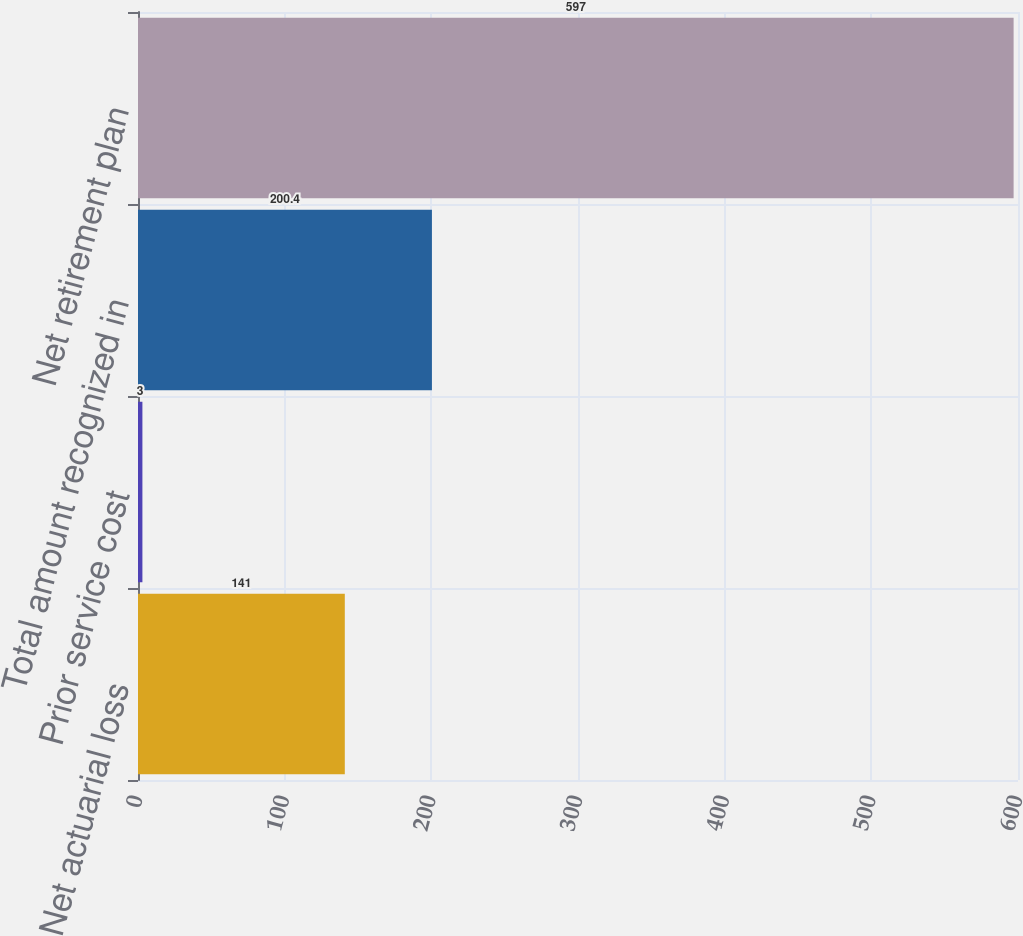<chart> <loc_0><loc_0><loc_500><loc_500><bar_chart><fcel>Net actuarial loss<fcel>Prior service cost<fcel>Total amount recognized in<fcel>Net retirement plan<nl><fcel>141<fcel>3<fcel>200.4<fcel>597<nl></chart> 